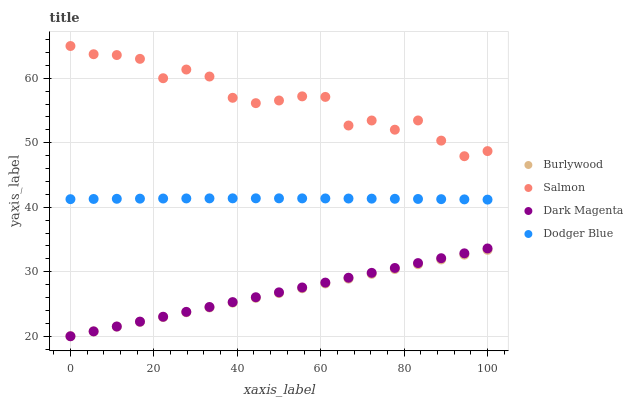Does Burlywood have the minimum area under the curve?
Answer yes or no. Yes. Does Salmon have the maximum area under the curve?
Answer yes or no. Yes. Does Dodger Blue have the minimum area under the curve?
Answer yes or no. No. Does Dodger Blue have the maximum area under the curve?
Answer yes or no. No. Is Burlywood the smoothest?
Answer yes or no. Yes. Is Salmon the roughest?
Answer yes or no. Yes. Is Dodger Blue the smoothest?
Answer yes or no. No. Is Dodger Blue the roughest?
Answer yes or no. No. Does Burlywood have the lowest value?
Answer yes or no. Yes. Does Dodger Blue have the lowest value?
Answer yes or no. No. Does Salmon have the highest value?
Answer yes or no. Yes. Does Dodger Blue have the highest value?
Answer yes or no. No. Is Dark Magenta less than Salmon?
Answer yes or no. Yes. Is Dodger Blue greater than Dark Magenta?
Answer yes or no. Yes. Does Burlywood intersect Dark Magenta?
Answer yes or no. Yes. Is Burlywood less than Dark Magenta?
Answer yes or no. No. Is Burlywood greater than Dark Magenta?
Answer yes or no. No. Does Dark Magenta intersect Salmon?
Answer yes or no. No. 